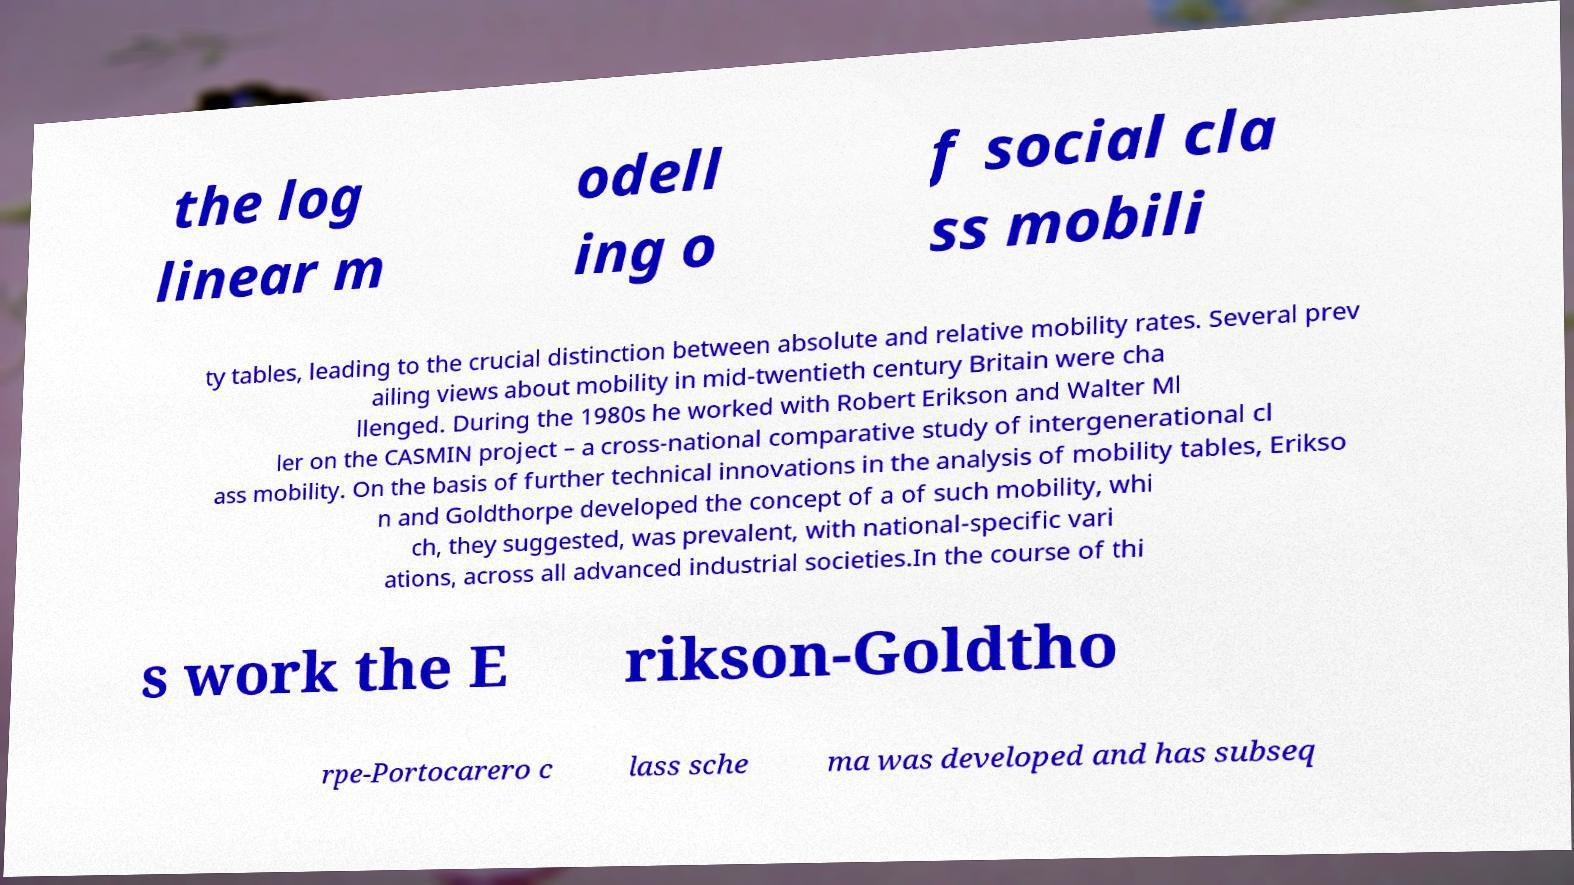What messages or text are displayed in this image? I need them in a readable, typed format. the log linear m odell ing o f social cla ss mobili ty tables, leading to the crucial distinction between absolute and relative mobility rates. Several prev ailing views about mobility in mid-twentieth century Britain were cha llenged. During the 1980s he worked with Robert Erikson and Walter Ml ler on the CASMIN project – a cross-national comparative study of intergenerational cl ass mobility. On the basis of further technical innovations in the analysis of mobility tables, Erikso n and Goldthorpe developed the concept of a of such mobility, whi ch, they suggested, was prevalent, with national-specific vari ations, across all advanced industrial societies.In the course of thi s work the E rikson-Goldtho rpe-Portocarero c lass sche ma was developed and has subseq 